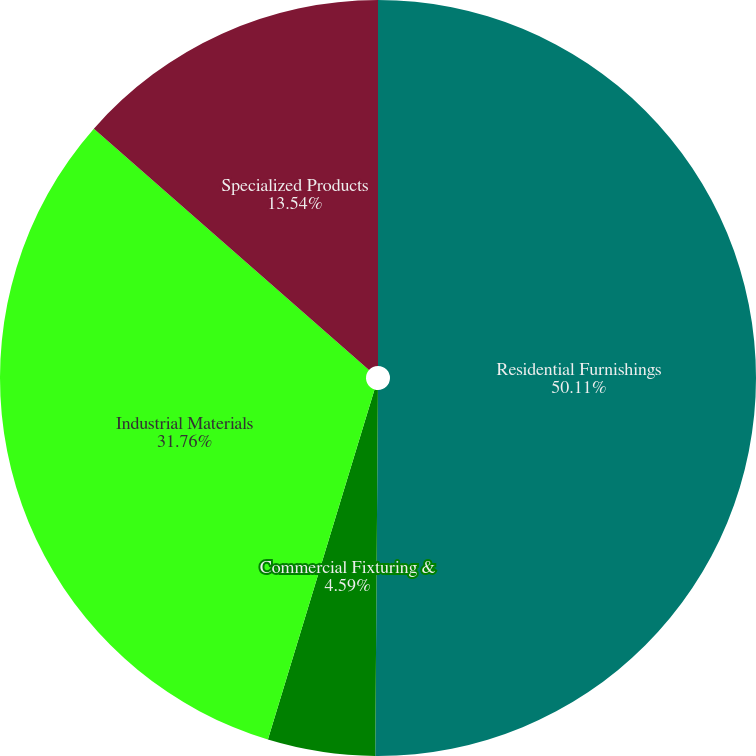<chart> <loc_0><loc_0><loc_500><loc_500><pie_chart><fcel>Residential Furnishings<fcel>Commercial Fixturing &<fcel>Industrial Materials<fcel>Specialized Products<nl><fcel>50.12%<fcel>4.59%<fcel>31.76%<fcel>13.54%<nl></chart> 